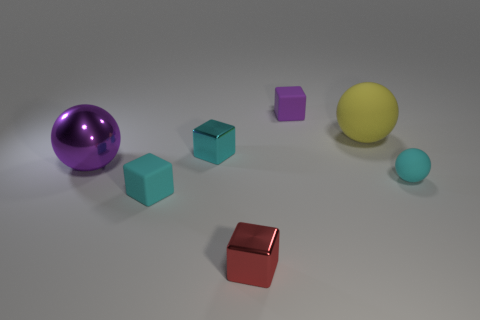Is the size of the cyan cube in front of the cyan metal cube the same as the big yellow ball?
Offer a very short reply. No. How many cyan metal things are the same size as the purple matte thing?
Ensure brevity in your answer.  1. There is a thing that is the same color as the large metallic ball; what size is it?
Provide a short and direct response. Small. There is a large rubber object; what shape is it?
Provide a succinct answer. Sphere. Is there another big ball of the same color as the large metal ball?
Offer a terse response. No. Is the number of small objects that are behind the large metallic sphere greater than the number of yellow spheres?
Give a very brief answer. Yes. There is a cyan shiny thing; is it the same shape as the small cyan rubber object on the left side of the small matte sphere?
Offer a terse response. Yes. Are there any big gray metal objects?
Your response must be concise. No. What number of big things are either cyan rubber balls or purple matte objects?
Ensure brevity in your answer.  0. Are there more cyan matte spheres that are behind the cyan rubber sphere than cyan shiny cubes in front of the small cyan matte cube?
Give a very brief answer. No. 